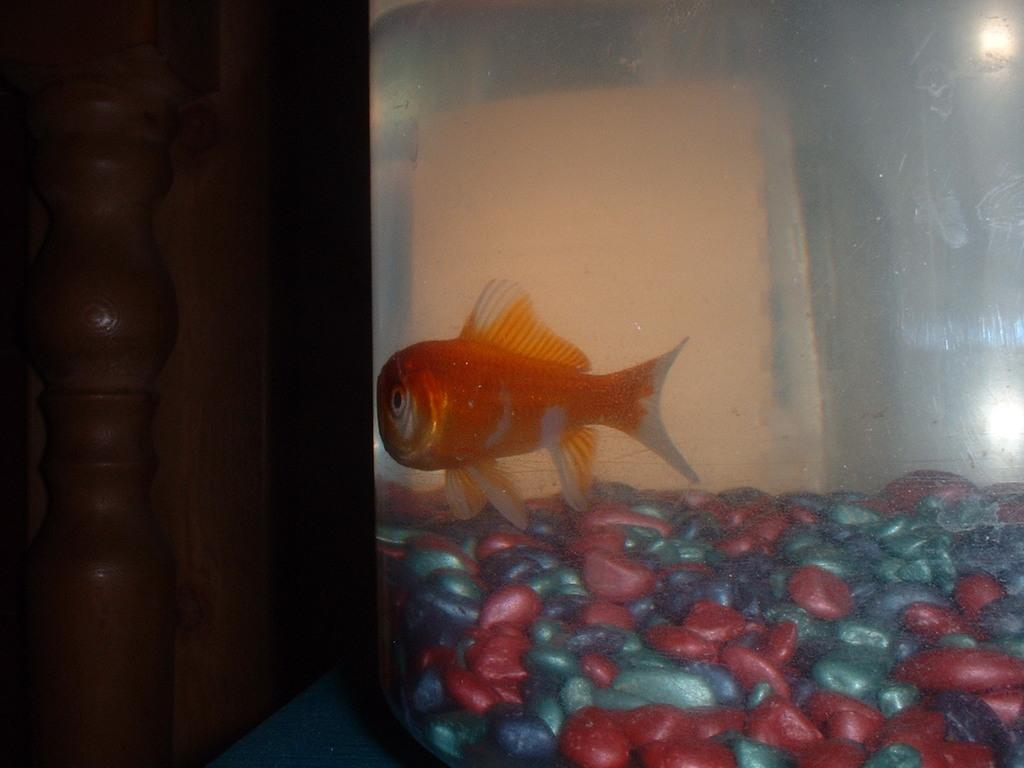What type of animal can be seen in the water in the image? There is a fish in the water in the image. What else is present in the water besides the fish? There are pebbles in the water. How would you describe the lighting in the image? The environment is dark. What type of calendar is hanging on the wall in the image? There is no wall or calendar present in the image; it features a fish in the water with pebbles. What event is taking place in the image? There is no specific event depicted in the image; it simply shows a fish in the water with pebbles in a dark environment. 